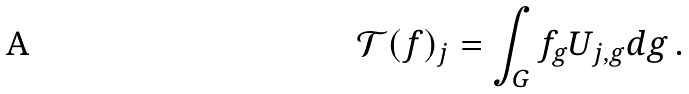Convert formula to latex. <formula><loc_0><loc_0><loc_500><loc_500>\mathcal { T } ( f ) _ { j } = \int _ { G } f _ { g } U _ { j , g } d g \, .</formula> 